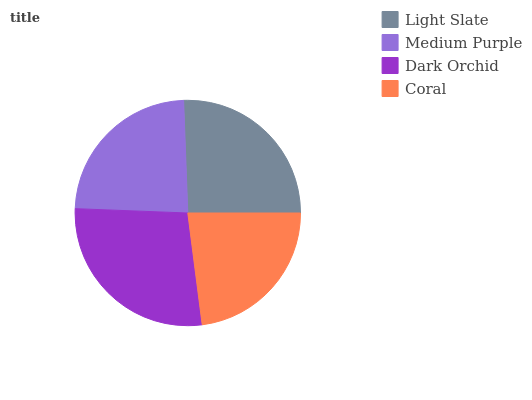Is Coral the minimum?
Answer yes or no. Yes. Is Dark Orchid the maximum?
Answer yes or no. Yes. Is Medium Purple the minimum?
Answer yes or no. No. Is Medium Purple the maximum?
Answer yes or no. No. Is Light Slate greater than Medium Purple?
Answer yes or no. Yes. Is Medium Purple less than Light Slate?
Answer yes or no. Yes. Is Medium Purple greater than Light Slate?
Answer yes or no. No. Is Light Slate less than Medium Purple?
Answer yes or no. No. Is Light Slate the high median?
Answer yes or no. Yes. Is Medium Purple the low median?
Answer yes or no. Yes. Is Medium Purple the high median?
Answer yes or no. No. Is Dark Orchid the low median?
Answer yes or no. No. 